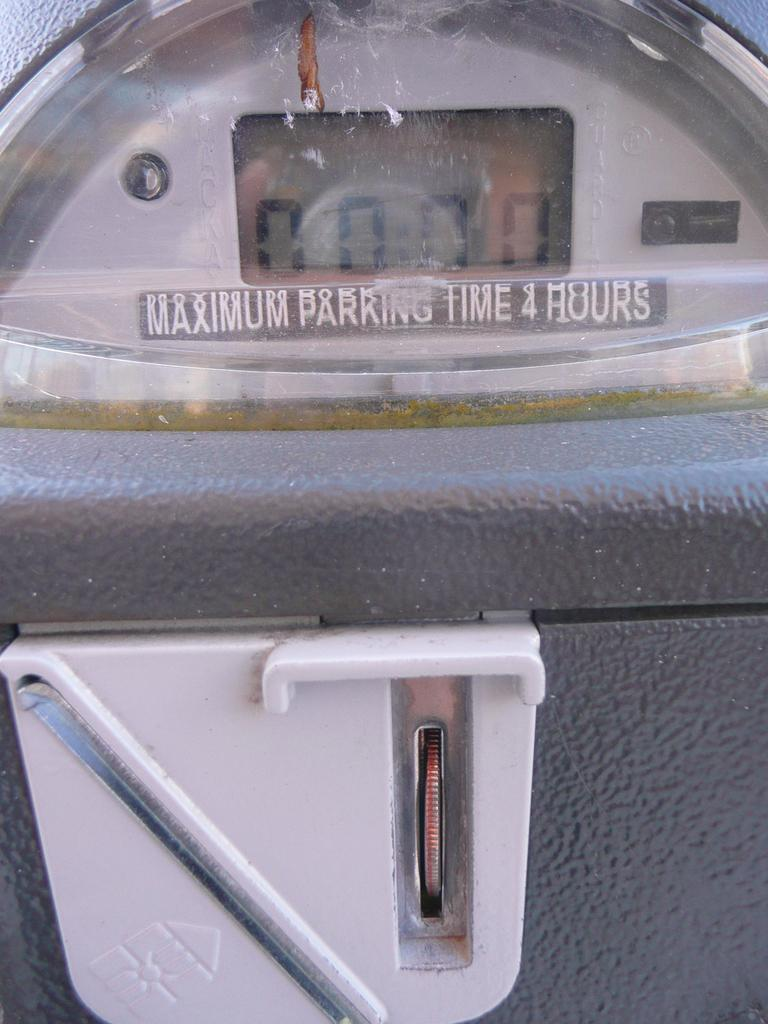Provide a one-sentence caption for the provided image. A parking meter is set to zero as a coin is being inserted. 